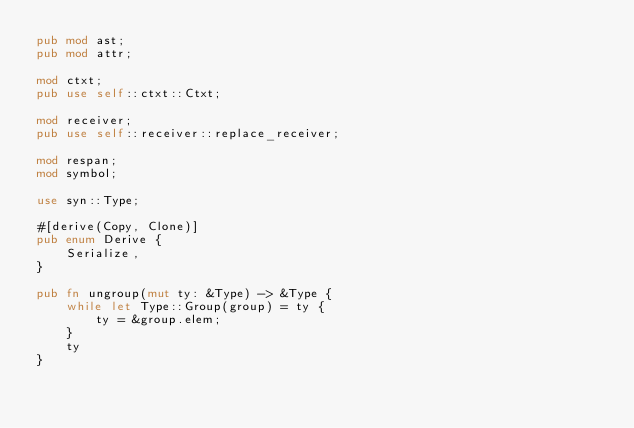Convert code to text. <code><loc_0><loc_0><loc_500><loc_500><_Rust_>pub mod ast;
pub mod attr;

mod ctxt;
pub use self::ctxt::Ctxt;

mod receiver;
pub use self::receiver::replace_receiver;

mod respan;
mod symbol;

use syn::Type;

#[derive(Copy, Clone)]
pub enum Derive {
    Serialize,
}

pub fn ungroup(mut ty: &Type) -> &Type {
    while let Type::Group(group) = ty {
        ty = &group.elem;
    }
    ty
}
</code> 